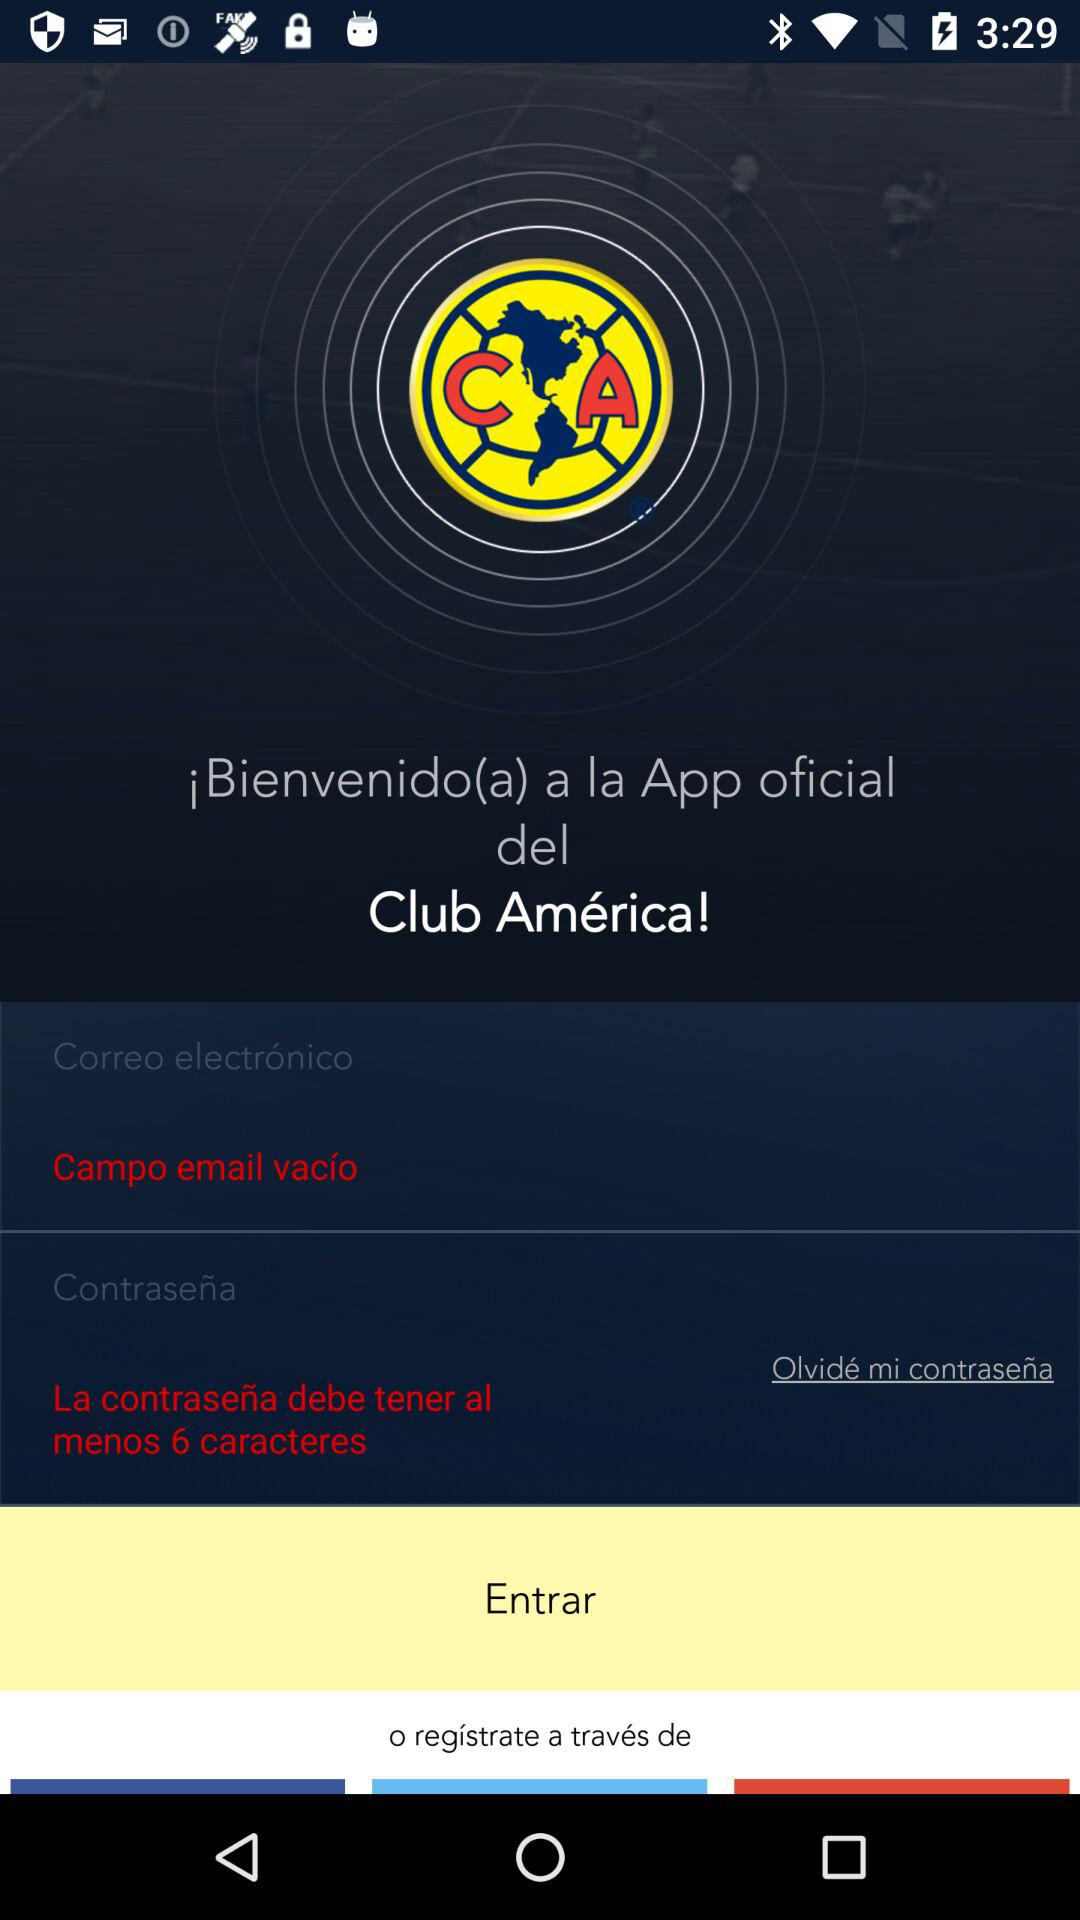How many text inputs are required to login to the app?
Answer the question using a single word or phrase. 2 